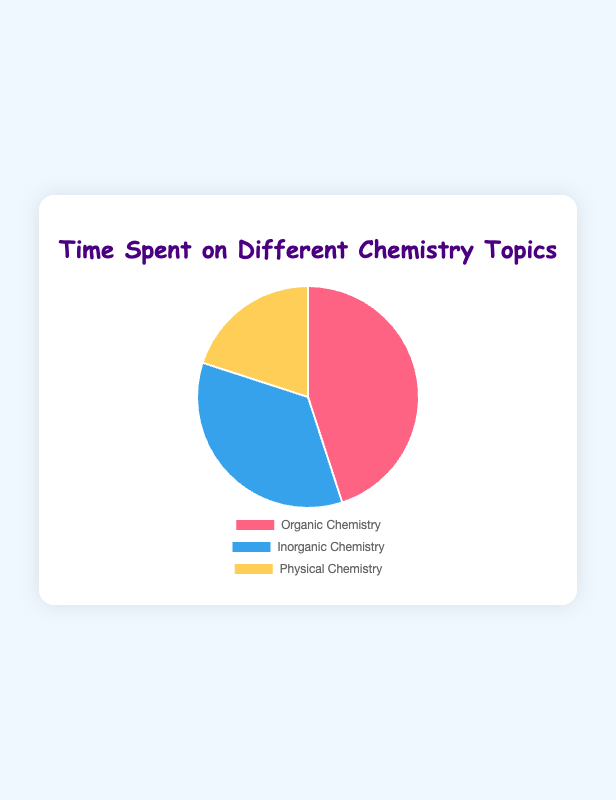How much time is spent on Organic and Physical Chemistry combined? Add the time spent on Organic Chemistry (45 hours) and Physical Chemistry (20 hours): 45 + 20 = 65 hours
Answer: 65 hours Which topic has the least amount of time spent on it? Compare the hours spent on each topic: Organic Chemistry (45 hours), Inorganic Chemistry (35 hours), Physical Chemistry (20 hours). The least is Physical Chemistry.
Answer: Physical Chemistry What percentage of the total time is spent on Inorganic Chemistry? Calculate the total time by adding all topics: 45 + 35 + 20 = 100. Then find the percentage: (35 / 100) * 100 = 35%
Answer: 35% How much more time is spent on Organic Chemistry compared to Physical Chemistry? Subtract the time spent on Physical Chemistry from Organic Chemistry: 45 - 20 = 25 hours
Answer: 25 hours Which color represents the Inorganic Chemistry section in the pie chart? The pie chart colors from the data: Organic Chemistry (red), Inorganic Chemistry (blue), Physical Chemistry (yellow). Thus, Inorganic Chemistry is blue.
Answer: Blue How much time on average is spent per topic? Calculate the total time and divide by the number of topics: 45 + 35 + 20 = 100, then 100 / 3 ≈ 33.33 hours
Answer: 33.33 hours What is the ratio of time spent on Organic Chemistry to Inorganic Chemistry? Divide the time spent on Organic Chemistry by the time spent on Inorganic Chemistry: 45 / 35 = 1.29
Answer: 1.29 Which topic takes up exactly one-fifth of the total time? Calculate one-fifth of the total time: 100 / 5 = 20. Physical Chemistry takes 20 hours.
Answer: Physical Chemistry Which two topics together make up more than half of the total time spent? Sum the time for each pair: 
(1) Organic + Inorganic = 45 + 35 = 80 hours 
(2) Organic + Physical = 45 + 20 = 65 hours 
(3) Inorganic + Physical = 35 + 20 = 55 hours. 
Only Organic + Inorganic is more than half the total time.
Answer: Organic Chemistry, Inorganic Chemistry What is the difference in time spent between the topic with the most time and the topic with the least time? Identify the topic with the most time (Organic Chemistry, 45 hours) and the least time (Physical Chemistry, 20 hours). Subtract: 45 - 20 = 25 hours
Answer: 25 hours 